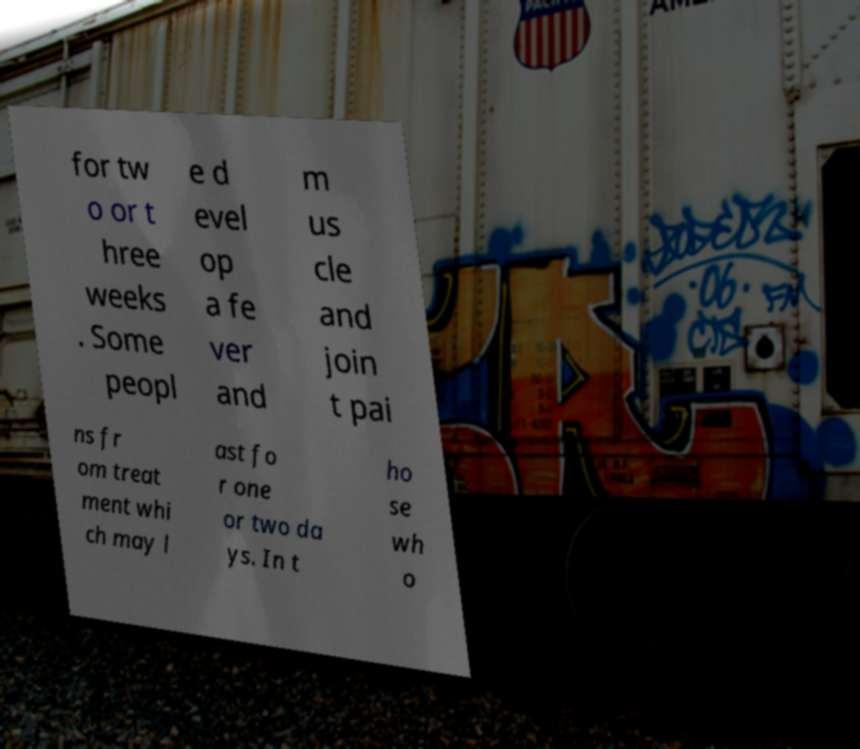Please identify and transcribe the text found in this image. for tw o or t hree weeks . Some peopl e d evel op a fe ver and m us cle and join t pai ns fr om treat ment whi ch may l ast fo r one or two da ys. In t ho se wh o 